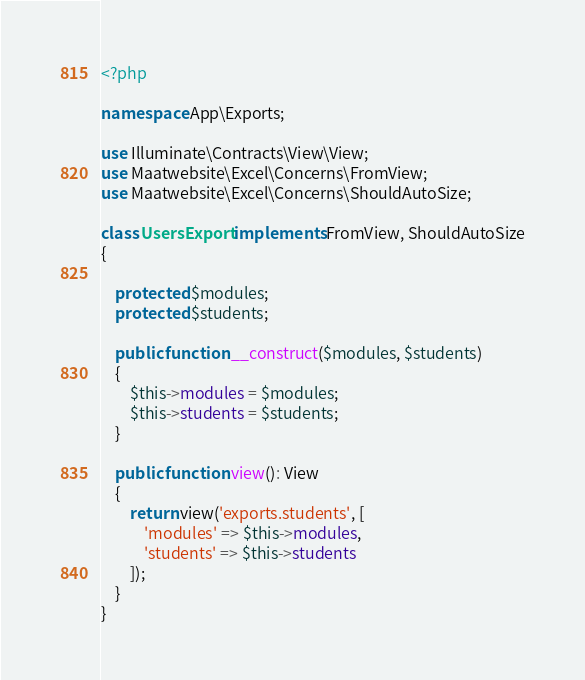<code> <loc_0><loc_0><loc_500><loc_500><_PHP_><?php

namespace App\Exports;

use Illuminate\Contracts\View\View;
use Maatwebsite\Excel\Concerns\FromView;
use Maatwebsite\Excel\Concerns\ShouldAutoSize;

class UsersExport implements FromView, ShouldAutoSize
{

    protected $modules;
    protected $students;

    public function __construct($modules, $students)
    {
        $this->modules = $modules;
        $this->students = $students;
    }

    public function view(): View
    {
        return view('exports.students', [
            'modules' => $this->modules,
            'students' => $this->students
        ]);
    }
}
</code> 